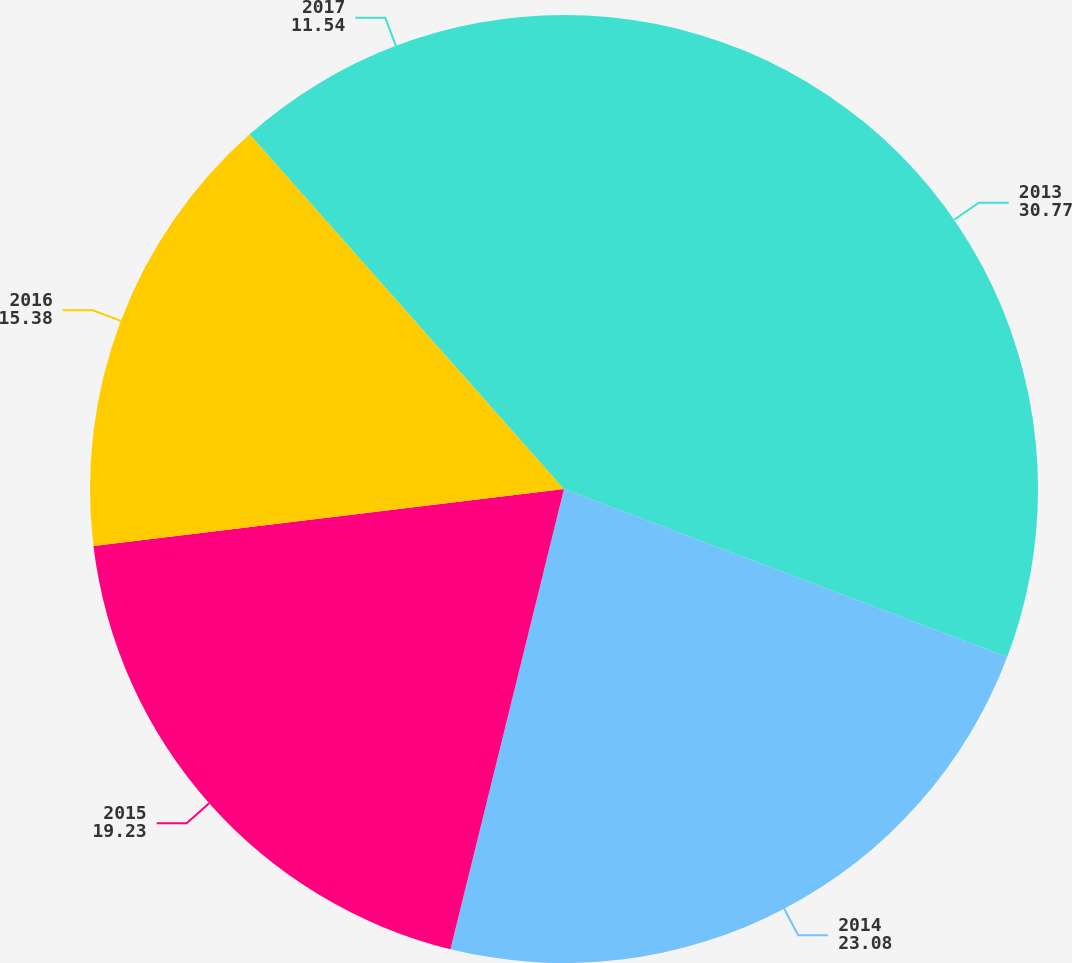Convert chart. <chart><loc_0><loc_0><loc_500><loc_500><pie_chart><fcel>2013<fcel>2014<fcel>2015<fcel>2016<fcel>2017<nl><fcel>30.77%<fcel>23.08%<fcel>19.23%<fcel>15.38%<fcel>11.54%<nl></chart> 